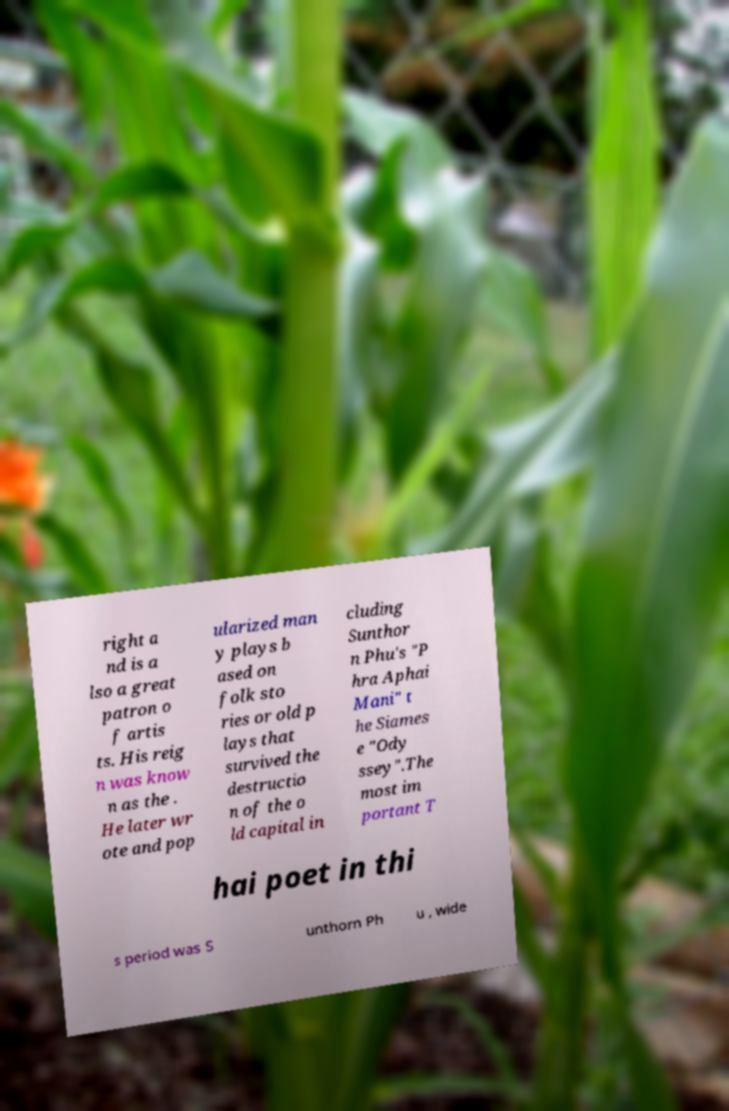I need the written content from this picture converted into text. Can you do that? right a nd is a lso a great patron o f artis ts. His reig n was know n as the . He later wr ote and pop ularized man y plays b ased on folk sto ries or old p lays that survived the destructio n of the o ld capital in cluding Sunthor n Phu's "P hra Aphai Mani" t he Siames e "Ody ssey".The most im portant T hai poet in thi s period was S unthorn Ph u , wide 